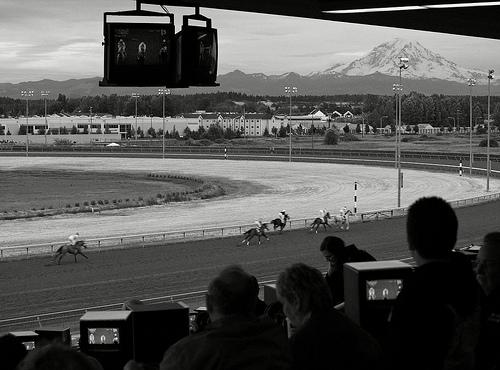Question: why are the horses running?
Choices:
A. They are escaping.
B. They are playing.
C. For exercise.
D. They are in a race.
Answer with the letter. Answer: D Question: what type of surface are the horses running on?
Choices:
A. Grass.
B. Dirt.
C. Cement.
D. Sand.
Answer with the letter. Answer: B Question: what are the people watching?
Choices:
A. A dog race.
B. A polo match.
C. A horse race.
D. The Kentucky derby.
Answer with the letter. Answer: C Question: what are the people called who are riding the horses?
Choices:
A. Jockeys.
B. Professionals.
C. Athletes.
D. Cowboys.
Answer with the letter. Answer: A 